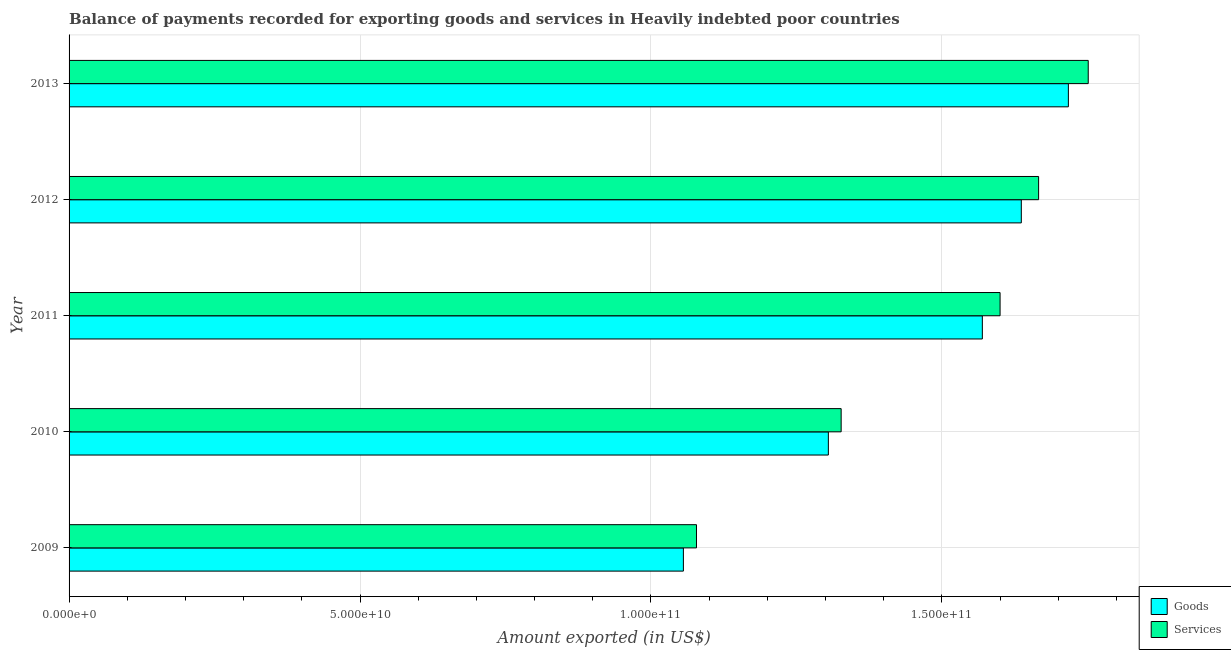How many different coloured bars are there?
Offer a very short reply. 2. How many groups of bars are there?
Your response must be concise. 5. Are the number of bars on each tick of the Y-axis equal?
Keep it short and to the point. Yes. How many bars are there on the 4th tick from the top?
Offer a terse response. 2. What is the label of the 3rd group of bars from the top?
Give a very brief answer. 2011. What is the amount of goods exported in 2010?
Ensure brevity in your answer.  1.30e+11. Across all years, what is the maximum amount of goods exported?
Ensure brevity in your answer.  1.72e+11. Across all years, what is the minimum amount of goods exported?
Keep it short and to the point. 1.06e+11. In which year was the amount of services exported minimum?
Offer a terse response. 2009. What is the total amount of goods exported in the graph?
Give a very brief answer. 7.28e+11. What is the difference between the amount of goods exported in 2011 and that in 2012?
Your response must be concise. -6.70e+09. What is the difference between the amount of goods exported in 2009 and the amount of services exported in 2010?
Ensure brevity in your answer.  -2.71e+1. What is the average amount of goods exported per year?
Your answer should be compact. 1.46e+11. In the year 2009, what is the difference between the amount of goods exported and amount of services exported?
Ensure brevity in your answer.  -2.25e+09. In how many years, is the amount of goods exported greater than 170000000000 US$?
Provide a succinct answer. 1. What is the ratio of the amount of goods exported in 2012 to that in 2013?
Make the answer very short. 0.95. Is the amount of services exported in 2010 less than that in 2012?
Provide a short and direct response. Yes. What is the difference between the highest and the second highest amount of goods exported?
Your response must be concise. 8.09e+09. What is the difference between the highest and the lowest amount of goods exported?
Ensure brevity in your answer.  6.62e+1. In how many years, is the amount of services exported greater than the average amount of services exported taken over all years?
Keep it short and to the point. 3. Is the sum of the amount of services exported in 2010 and 2011 greater than the maximum amount of goods exported across all years?
Your answer should be very brief. Yes. What does the 1st bar from the top in 2011 represents?
Your response must be concise. Services. What does the 2nd bar from the bottom in 2013 represents?
Your answer should be compact. Services. How many bars are there?
Provide a short and direct response. 10. How many years are there in the graph?
Provide a succinct answer. 5. Are the values on the major ticks of X-axis written in scientific E-notation?
Your answer should be very brief. Yes. Does the graph contain any zero values?
Your answer should be very brief. No. How many legend labels are there?
Make the answer very short. 2. What is the title of the graph?
Keep it short and to the point. Balance of payments recorded for exporting goods and services in Heavily indebted poor countries. Does "From production" appear as one of the legend labels in the graph?
Offer a very short reply. No. What is the label or title of the X-axis?
Provide a short and direct response. Amount exported (in US$). What is the Amount exported (in US$) in Goods in 2009?
Make the answer very short. 1.06e+11. What is the Amount exported (in US$) of Services in 2009?
Provide a short and direct response. 1.08e+11. What is the Amount exported (in US$) of Goods in 2010?
Make the answer very short. 1.30e+11. What is the Amount exported (in US$) in Services in 2010?
Make the answer very short. 1.33e+11. What is the Amount exported (in US$) of Goods in 2011?
Ensure brevity in your answer.  1.57e+11. What is the Amount exported (in US$) in Services in 2011?
Offer a very short reply. 1.60e+11. What is the Amount exported (in US$) of Goods in 2012?
Offer a very short reply. 1.64e+11. What is the Amount exported (in US$) in Services in 2012?
Provide a succinct answer. 1.67e+11. What is the Amount exported (in US$) in Goods in 2013?
Your answer should be very brief. 1.72e+11. What is the Amount exported (in US$) of Services in 2013?
Your answer should be compact. 1.75e+11. Across all years, what is the maximum Amount exported (in US$) in Goods?
Your response must be concise. 1.72e+11. Across all years, what is the maximum Amount exported (in US$) in Services?
Your answer should be compact. 1.75e+11. Across all years, what is the minimum Amount exported (in US$) in Goods?
Offer a terse response. 1.06e+11. Across all years, what is the minimum Amount exported (in US$) of Services?
Give a very brief answer. 1.08e+11. What is the total Amount exported (in US$) in Goods in the graph?
Keep it short and to the point. 7.28e+11. What is the total Amount exported (in US$) of Services in the graph?
Make the answer very short. 7.42e+11. What is the difference between the Amount exported (in US$) of Goods in 2009 and that in 2010?
Your response must be concise. -2.49e+1. What is the difference between the Amount exported (in US$) of Services in 2009 and that in 2010?
Your answer should be compact. -2.49e+1. What is the difference between the Amount exported (in US$) of Goods in 2009 and that in 2011?
Provide a short and direct response. -5.14e+1. What is the difference between the Amount exported (in US$) of Services in 2009 and that in 2011?
Your answer should be compact. -5.22e+1. What is the difference between the Amount exported (in US$) in Goods in 2009 and that in 2012?
Offer a very short reply. -5.81e+1. What is the difference between the Amount exported (in US$) of Services in 2009 and that in 2012?
Make the answer very short. -5.88e+1. What is the difference between the Amount exported (in US$) in Goods in 2009 and that in 2013?
Offer a terse response. -6.62e+1. What is the difference between the Amount exported (in US$) of Services in 2009 and that in 2013?
Make the answer very short. -6.73e+1. What is the difference between the Amount exported (in US$) of Goods in 2010 and that in 2011?
Offer a very short reply. -2.65e+1. What is the difference between the Amount exported (in US$) of Services in 2010 and that in 2011?
Keep it short and to the point. -2.73e+1. What is the difference between the Amount exported (in US$) of Goods in 2010 and that in 2012?
Offer a terse response. -3.32e+1. What is the difference between the Amount exported (in US$) in Services in 2010 and that in 2012?
Give a very brief answer. -3.39e+1. What is the difference between the Amount exported (in US$) in Goods in 2010 and that in 2013?
Give a very brief answer. -4.12e+1. What is the difference between the Amount exported (in US$) in Services in 2010 and that in 2013?
Your response must be concise. -4.25e+1. What is the difference between the Amount exported (in US$) in Goods in 2011 and that in 2012?
Ensure brevity in your answer.  -6.70e+09. What is the difference between the Amount exported (in US$) of Services in 2011 and that in 2012?
Ensure brevity in your answer.  -6.62e+09. What is the difference between the Amount exported (in US$) of Goods in 2011 and that in 2013?
Provide a succinct answer. -1.48e+1. What is the difference between the Amount exported (in US$) in Services in 2011 and that in 2013?
Your answer should be compact. -1.52e+1. What is the difference between the Amount exported (in US$) of Goods in 2012 and that in 2013?
Keep it short and to the point. -8.09e+09. What is the difference between the Amount exported (in US$) of Services in 2012 and that in 2013?
Offer a very short reply. -8.53e+09. What is the difference between the Amount exported (in US$) in Goods in 2009 and the Amount exported (in US$) in Services in 2010?
Your answer should be compact. -2.71e+1. What is the difference between the Amount exported (in US$) of Goods in 2009 and the Amount exported (in US$) of Services in 2011?
Keep it short and to the point. -5.44e+1. What is the difference between the Amount exported (in US$) in Goods in 2009 and the Amount exported (in US$) in Services in 2012?
Make the answer very short. -6.10e+1. What is the difference between the Amount exported (in US$) of Goods in 2009 and the Amount exported (in US$) of Services in 2013?
Make the answer very short. -6.96e+1. What is the difference between the Amount exported (in US$) in Goods in 2010 and the Amount exported (in US$) in Services in 2011?
Offer a very short reply. -2.95e+1. What is the difference between the Amount exported (in US$) in Goods in 2010 and the Amount exported (in US$) in Services in 2012?
Your answer should be compact. -3.61e+1. What is the difference between the Amount exported (in US$) of Goods in 2010 and the Amount exported (in US$) of Services in 2013?
Offer a very short reply. -4.47e+1. What is the difference between the Amount exported (in US$) of Goods in 2011 and the Amount exported (in US$) of Services in 2012?
Keep it short and to the point. -9.67e+09. What is the difference between the Amount exported (in US$) in Goods in 2011 and the Amount exported (in US$) in Services in 2013?
Your answer should be very brief. -1.82e+1. What is the difference between the Amount exported (in US$) in Goods in 2012 and the Amount exported (in US$) in Services in 2013?
Ensure brevity in your answer.  -1.15e+1. What is the average Amount exported (in US$) in Goods per year?
Your answer should be very brief. 1.46e+11. What is the average Amount exported (in US$) in Services per year?
Give a very brief answer. 1.48e+11. In the year 2009, what is the difference between the Amount exported (in US$) in Goods and Amount exported (in US$) in Services?
Provide a short and direct response. -2.25e+09. In the year 2010, what is the difference between the Amount exported (in US$) of Goods and Amount exported (in US$) of Services?
Provide a succinct answer. -2.20e+09. In the year 2011, what is the difference between the Amount exported (in US$) of Goods and Amount exported (in US$) of Services?
Make the answer very short. -3.05e+09. In the year 2012, what is the difference between the Amount exported (in US$) of Goods and Amount exported (in US$) of Services?
Your response must be concise. -2.97e+09. In the year 2013, what is the difference between the Amount exported (in US$) in Goods and Amount exported (in US$) in Services?
Keep it short and to the point. -3.41e+09. What is the ratio of the Amount exported (in US$) of Goods in 2009 to that in 2010?
Offer a very short reply. 0.81. What is the ratio of the Amount exported (in US$) in Services in 2009 to that in 2010?
Provide a short and direct response. 0.81. What is the ratio of the Amount exported (in US$) of Goods in 2009 to that in 2011?
Give a very brief answer. 0.67. What is the ratio of the Amount exported (in US$) in Services in 2009 to that in 2011?
Provide a succinct answer. 0.67. What is the ratio of the Amount exported (in US$) in Goods in 2009 to that in 2012?
Offer a very short reply. 0.65. What is the ratio of the Amount exported (in US$) of Services in 2009 to that in 2012?
Your answer should be compact. 0.65. What is the ratio of the Amount exported (in US$) in Goods in 2009 to that in 2013?
Offer a very short reply. 0.61. What is the ratio of the Amount exported (in US$) of Services in 2009 to that in 2013?
Provide a succinct answer. 0.62. What is the ratio of the Amount exported (in US$) of Goods in 2010 to that in 2011?
Offer a very short reply. 0.83. What is the ratio of the Amount exported (in US$) of Services in 2010 to that in 2011?
Offer a very short reply. 0.83. What is the ratio of the Amount exported (in US$) in Goods in 2010 to that in 2012?
Your answer should be compact. 0.8. What is the ratio of the Amount exported (in US$) of Services in 2010 to that in 2012?
Your answer should be very brief. 0.8. What is the ratio of the Amount exported (in US$) in Goods in 2010 to that in 2013?
Make the answer very short. 0.76. What is the ratio of the Amount exported (in US$) in Services in 2010 to that in 2013?
Make the answer very short. 0.76. What is the ratio of the Amount exported (in US$) in Goods in 2011 to that in 2012?
Make the answer very short. 0.96. What is the ratio of the Amount exported (in US$) of Services in 2011 to that in 2012?
Offer a very short reply. 0.96. What is the ratio of the Amount exported (in US$) in Goods in 2011 to that in 2013?
Provide a short and direct response. 0.91. What is the ratio of the Amount exported (in US$) in Services in 2011 to that in 2013?
Offer a terse response. 0.91. What is the ratio of the Amount exported (in US$) of Goods in 2012 to that in 2013?
Make the answer very short. 0.95. What is the ratio of the Amount exported (in US$) of Services in 2012 to that in 2013?
Your answer should be compact. 0.95. What is the difference between the highest and the second highest Amount exported (in US$) in Goods?
Offer a very short reply. 8.09e+09. What is the difference between the highest and the second highest Amount exported (in US$) in Services?
Offer a very short reply. 8.53e+09. What is the difference between the highest and the lowest Amount exported (in US$) of Goods?
Give a very brief answer. 6.62e+1. What is the difference between the highest and the lowest Amount exported (in US$) in Services?
Provide a short and direct response. 6.73e+1. 